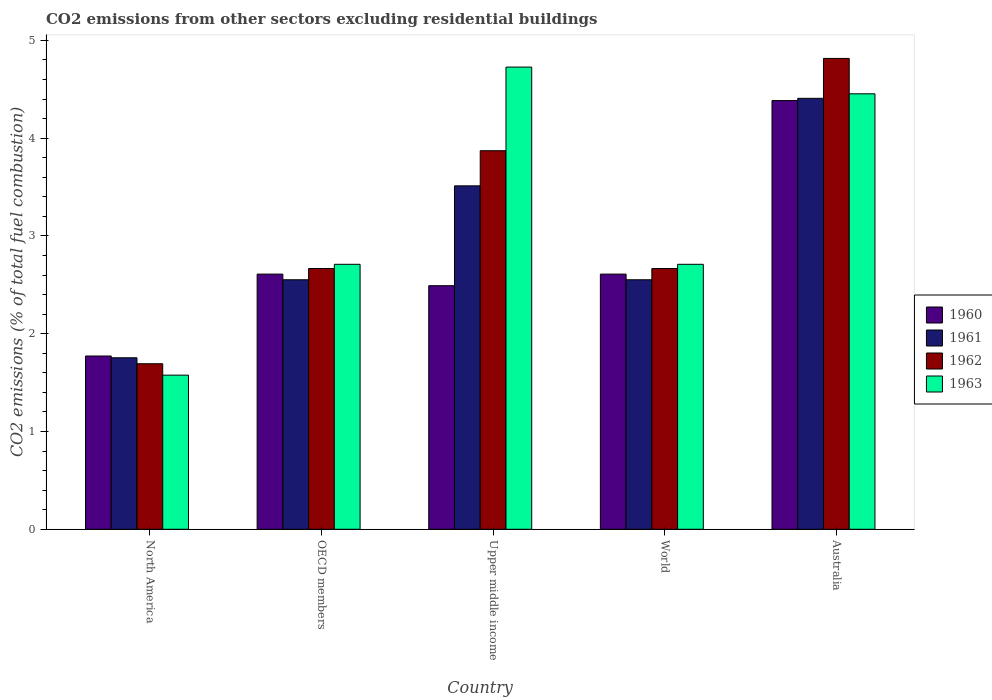How many different coloured bars are there?
Keep it short and to the point. 4. How many groups of bars are there?
Offer a very short reply. 5. Are the number of bars per tick equal to the number of legend labels?
Make the answer very short. Yes. How many bars are there on the 5th tick from the right?
Provide a short and direct response. 4. What is the label of the 2nd group of bars from the left?
Your answer should be compact. OECD members. What is the total CO2 emitted in 1960 in OECD members?
Your response must be concise. 2.61. Across all countries, what is the maximum total CO2 emitted in 1962?
Your answer should be compact. 4.82. Across all countries, what is the minimum total CO2 emitted in 1963?
Your answer should be compact. 1.58. In which country was the total CO2 emitted in 1963 maximum?
Provide a succinct answer. Upper middle income. What is the total total CO2 emitted in 1961 in the graph?
Ensure brevity in your answer.  14.78. What is the difference between the total CO2 emitted in 1961 in Australia and that in World?
Provide a short and direct response. 1.86. What is the difference between the total CO2 emitted in 1963 in Australia and the total CO2 emitted in 1960 in Upper middle income?
Your answer should be compact. 1.96. What is the average total CO2 emitted in 1960 per country?
Ensure brevity in your answer.  2.77. What is the difference between the total CO2 emitted of/in 1962 and total CO2 emitted of/in 1961 in OECD members?
Make the answer very short. 0.11. What is the ratio of the total CO2 emitted in 1961 in Australia to that in World?
Make the answer very short. 1.73. Is the total CO2 emitted in 1963 in North America less than that in Upper middle income?
Offer a terse response. Yes. Is the difference between the total CO2 emitted in 1962 in Australia and World greater than the difference between the total CO2 emitted in 1961 in Australia and World?
Keep it short and to the point. Yes. What is the difference between the highest and the second highest total CO2 emitted in 1962?
Offer a very short reply. -1.2. What is the difference between the highest and the lowest total CO2 emitted in 1960?
Your response must be concise. 2.61. Is the sum of the total CO2 emitted in 1963 in OECD members and World greater than the maximum total CO2 emitted in 1962 across all countries?
Your answer should be very brief. Yes. What does the 2nd bar from the left in North America represents?
Offer a very short reply. 1961. What does the 2nd bar from the right in Australia represents?
Ensure brevity in your answer.  1962. Is it the case that in every country, the sum of the total CO2 emitted in 1960 and total CO2 emitted in 1963 is greater than the total CO2 emitted in 1961?
Your answer should be very brief. Yes. How many bars are there?
Offer a terse response. 20. Are all the bars in the graph horizontal?
Make the answer very short. No. Are the values on the major ticks of Y-axis written in scientific E-notation?
Make the answer very short. No. Does the graph contain any zero values?
Offer a very short reply. No. Where does the legend appear in the graph?
Make the answer very short. Center right. How many legend labels are there?
Provide a succinct answer. 4. How are the legend labels stacked?
Your answer should be compact. Vertical. What is the title of the graph?
Keep it short and to the point. CO2 emissions from other sectors excluding residential buildings. Does "2003" appear as one of the legend labels in the graph?
Offer a very short reply. No. What is the label or title of the X-axis?
Your response must be concise. Country. What is the label or title of the Y-axis?
Your answer should be very brief. CO2 emissions (% of total fuel combustion). What is the CO2 emissions (% of total fuel combustion) in 1960 in North America?
Provide a short and direct response. 1.77. What is the CO2 emissions (% of total fuel combustion) of 1961 in North America?
Keep it short and to the point. 1.75. What is the CO2 emissions (% of total fuel combustion) of 1962 in North America?
Offer a terse response. 1.69. What is the CO2 emissions (% of total fuel combustion) in 1963 in North America?
Your answer should be very brief. 1.58. What is the CO2 emissions (% of total fuel combustion) in 1960 in OECD members?
Your answer should be very brief. 2.61. What is the CO2 emissions (% of total fuel combustion) in 1961 in OECD members?
Keep it short and to the point. 2.55. What is the CO2 emissions (% of total fuel combustion) of 1962 in OECD members?
Ensure brevity in your answer.  2.67. What is the CO2 emissions (% of total fuel combustion) of 1963 in OECD members?
Provide a succinct answer. 2.71. What is the CO2 emissions (% of total fuel combustion) in 1960 in Upper middle income?
Offer a terse response. 2.49. What is the CO2 emissions (% of total fuel combustion) in 1961 in Upper middle income?
Provide a short and direct response. 3.51. What is the CO2 emissions (% of total fuel combustion) in 1962 in Upper middle income?
Your response must be concise. 3.87. What is the CO2 emissions (% of total fuel combustion) in 1963 in Upper middle income?
Make the answer very short. 4.73. What is the CO2 emissions (% of total fuel combustion) of 1960 in World?
Your answer should be compact. 2.61. What is the CO2 emissions (% of total fuel combustion) of 1961 in World?
Ensure brevity in your answer.  2.55. What is the CO2 emissions (% of total fuel combustion) in 1962 in World?
Provide a succinct answer. 2.67. What is the CO2 emissions (% of total fuel combustion) in 1963 in World?
Provide a short and direct response. 2.71. What is the CO2 emissions (% of total fuel combustion) of 1960 in Australia?
Offer a terse response. 4.38. What is the CO2 emissions (% of total fuel combustion) of 1961 in Australia?
Provide a short and direct response. 4.41. What is the CO2 emissions (% of total fuel combustion) of 1962 in Australia?
Give a very brief answer. 4.82. What is the CO2 emissions (% of total fuel combustion) in 1963 in Australia?
Provide a succinct answer. 4.45. Across all countries, what is the maximum CO2 emissions (% of total fuel combustion) of 1960?
Provide a short and direct response. 4.38. Across all countries, what is the maximum CO2 emissions (% of total fuel combustion) in 1961?
Provide a short and direct response. 4.41. Across all countries, what is the maximum CO2 emissions (% of total fuel combustion) of 1962?
Offer a terse response. 4.82. Across all countries, what is the maximum CO2 emissions (% of total fuel combustion) of 1963?
Your response must be concise. 4.73. Across all countries, what is the minimum CO2 emissions (% of total fuel combustion) in 1960?
Offer a very short reply. 1.77. Across all countries, what is the minimum CO2 emissions (% of total fuel combustion) of 1961?
Keep it short and to the point. 1.75. Across all countries, what is the minimum CO2 emissions (% of total fuel combustion) of 1962?
Give a very brief answer. 1.69. Across all countries, what is the minimum CO2 emissions (% of total fuel combustion) in 1963?
Ensure brevity in your answer.  1.58. What is the total CO2 emissions (% of total fuel combustion) in 1960 in the graph?
Your answer should be compact. 13.87. What is the total CO2 emissions (% of total fuel combustion) in 1961 in the graph?
Provide a succinct answer. 14.78. What is the total CO2 emissions (% of total fuel combustion) of 1962 in the graph?
Your response must be concise. 15.71. What is the total CO2 emissions (% of total fuel combustion) of 1963 in the graph?
Ensure brevity in your answer.  16.17. What is the difference between the CO2 emissions (% of total fuel combustion) of 1960 in North America and that in OECD members?
Make the answer very short. -0.84. What is the difference between the CO2 emissions (% of total fuel combustion) in 1961 in North America and that in OECD members?
Ensure brevity in your answer.  -0.8. What is the difference between the CO2 emissions (% of total fuel combustion) of 1962 in North America and that in OECD members?
Give a very brief answer. -0.97. What is the difference between the CO2 emissions (% of total fuel combustion) in 1963 in North America and that in OECD members?
Give a very brief answer. -1.13. What is the difference between the CO2 emissions (% of total fuel combustion) of 1960 in North America and that in Upper middle income?
Provide a succinct answer. -0.72. What is the difference between the CO2 emissions (% of total fuel combustion) of 1961 in North America and that in Upper middle income?
Provide a short and direct response. -1.76. What is the difference between the CO2 emissions (% of total fuel combustion) in 1962 in North America and that in Upper middle income?
Provide a succinct answer. -2.18. What is the difference between the CO2 emissions (% of total fuel combustion) in 1963 in North America and that in Upper middle income?
Ensure brevity in your answer.  -3.15. What is the difference between the CO2 emissions (% of total fuel combustion) in 1960 in North America and that in World?
Offer a terse response. -0.84. What is the difference between the CO2 emissions (% of total fuel combustion) of 1961 in North America and that in World?
Make the answer very short. -0.8. What is the difference between the CO2 emissions (% of total fuel combustion) in 1962 in North America and that in World?
Your answer should be compact. -0.97. What is the difference between the CO2 emissions (% of total fuel combustion) in 1963 in North America and that in World?
Offer a very short reply. -1.13. What is the difference between the CO2 emissions (% of total fuel combustion) of 1960 in North America and that in Australia?
Give a very brief answer. -2.61. What is the difference between the CO2 emissions (% of total fuel combustion) in 1961 in North America and that in Australia?
Offer a very short reply. -2.65. What is the difference between the CO2 emissions (% of total fuel combustion) in 1962 in North America and that in Australia?
Your answer should be compact. -3.12. What is the difference between the CO2 emissions (% of total fuel combustion) of 1963 in North America and that in Australia?
Provide a short and direct response. -2.88. What is the difference between the CO2 emissions (% of total fuel combustion) of 1960 in OECD members and that in Upper middle income?
Provide a short and direct response. 0.12. What is the difference between the CO2 emissions (% of total fuel combustion) of 1961 in OECD members and that in Upper middle income?
Give a very brief answer. -0.96. What is the difference between the CO2 emissions (% of total fuel combustion) of 1962 in OECD members and that in Upper middle income?
Provide a succinct answer. -1.2. What is the difference between the CO2 emissions (% of total fuel combustion) in 1963 in OECD members and that in Upper middle income?
Provide a short and direct response. -2.02. What is the difference between the CO2 emissions (% of total fuel combustion) of 1961 in OECD members and that in World?
Offer a very short reply. 0. What is the difference between the CO2 emissions (% of total fuel combustion) of 1963 in OECD members and that in World?
Your response must be concise. 0. What is the difference between the CO2 emissions (% of total fuel combustion) of 1960 in OECD members and that in Australia?
Offer a very short reply. -1.77. What is the difference between the CO2 emissions (% of total fuel combustion) of 1961 in OECD members and that in Australia?
Your answer should be compact. -1.86. What is the difference between the CO2 emissions (% of total fuel combustion) in 1962 in OECD members and that in Australia?
Keep it short and to the point. -2.15. What is the difference between the CO2 emissions (% of total fuel combustion) of 1963 in OECD members and that in Australia?
Your answer should be very brief. -1.74. What is the difference between the CO2 emissions (% of total fuel combustion) in 1960 in Upper middle income and that in World?
Keep it short and to the point. -0.12. What is the difference between the CO2 emissions (% of total fuel combustion) of 1961 in Upper middle income and that in World?
Ensure brevity in your answer.  0.96. What is the difference between the CO2 emissions (% of total fuel combustion) of 1962 in Upper middle income and that in World?
Make the answer very short. 1.2. What is the difference between the CO2 emissions (% of total fuel combustion) in 1963 in Upper middle income and that in World?
Offer a very short reply. 2.02. What is the difference between the CO2 emissions (% of total fuel combustion) of 1960 in Upper middle income and that in Australia?
Keep it short and to the point. -1.89. What is the difference between the CO2 emissions (% of total fuel combustion) of 1961 in Upper middle income and that in Australia?
Your answer should be very brief. -0.9. What is the difference between the CO2 emissions (% of total fuel combustion) of 1962 in Upper middle income and that in Australia?
Your answer should be compact. -0.94. What is the difference between the CO2 emissions (% of total fuel combustion) of 1963 in Upper middle income and that in Australia?
Make the answer very short. 0.27. What is the difference between the CO2 emissions (% of total fuel combustion) of 1960 in World and that in Australia?
Provide a succinct answer. -1.77. What is the difference between the CO2 emissions (% of total fuel combustion) of 1961 in World and that in Australia?
Provide a succinct answer. -1.86. What is the difference between the CO2 emissions (% of total fuel combustion) of 1962 in World and that in Australia?
Make the answer very short. -2.15. What is the difference between the CO2 emissions (% of total fuel combustion) of 1963 in World and that in Australia?
Offer a terse response. -1.74. What is the difference between the CO2 emissions (% of total fuel combustion) of 1960 in North America and the CO2 emissions (% of total fuel combustion) of 1961 in OECD members?
Your answer should be very brief. -0.78. What is the difference between the CO2 emissions (% of total fuel combustion) of 1960 in North America and the CO2 emissions (% of total fuel combustion) of 1962 in OECD members?
Offer a very short reply. -0.89. What is the difference between the CO2 emissions (% of total fuel combustion) in 1960 in North America and the CO2 emissions (% of total fuel combustion) in 1963 in OECD members?
Your answer should be very brief. -0.94. What is the difference between the CO2 emissions (% of total fuel combustion) of 1961 in North America and the CO2 emissions (% of total fuel combustion) of 1962 in OECD members?
Keep it short and to the point. -0.91. What is the difference between the CO2 emissions (% of total fuel combustion) of 1961 in North America and the CO2 emissions (% of total fuel combustion) of 1963 in OECD members?
Your response must be concise. -0.96. What is the difference between the CO2 emissions (% of total fuel combustion) of 1962 in North America and the CO2 emissions (% of total fuel combustion) of 1963 in OECD members?
Your answer should be very brief. -1.02. What is the difference between the CO2 emissions (% of total fuel combustion) of 1960 in North America and the CO2 emissions (% of total fuel combustion) of 1961 in Upper middle income?
Provide a succinct answer. -1.74. What is the difference between the CO2 emissions (% of total fuel combustion) in 1960 in North America and the CO2 emissions (% of total fuel combustion) in 1962 in Upper middle income?
Keep it short and to the point. -2.1. What is the difference between the CO2 emissions (% of total fuel combustion) in 1960 in North America and the CO2 emissions (% of total fuel combustion) in 1963 in Upper middle income?
Your answer should be compact. -2.95. What is the difference between the CO2 emissions (% of total fuel combustion) of 1961 in North America and the CO2 emissions (% of total fuel combustion) of 1962 in Upper middle income?
Your answer should be very brief. -2.12. What is the difference between the CO2 emissions (% of total fuel combustion) of 1961 in North America and the CO2 emissions (% of total fuel combustion) of 1963 in Upper middle income?
Make the answer very short. -2.97. What is the difference between the CO2 emissions (% of total fuel combustion) in 1962 in North America and the CO2 emissions (% of total fuel combustion) in 1963 in Upper middle income?
Give a very brief answer. -3.03. What is the difference between the CO2 emissions (% of total fuel combustion) of 1960 in North America and the CO2 emissions (% of total fuel combustion) of 1961 in World?
Provide a succinct answer. -0.78. What is the difference between the CO2 emissions (% of total fuel combustion) in 1960 in North America and the CO2 emissions (% of total fuel combustion) in 1962 in World?
Your answer should be compact. -0.89. What is the difference between the CO2 emissions (% of total fuel combustion) of 1960 in North America and the CO2 emissions (% of total fuel combustion) of 1963 in World?
Provide a short and direct response. -0.94. What is the difference between the CO2 emissions (% of total fuel combustion) in 1961 in North America and the CO2 emissions (% of total fuel combustion) in 1962 in World?
Offer a terse response. -0.91. What is the difference between the CO2 emissions (% of total fuel combustion) in 1961 in North America and the CO2 emissions (% of total fuel combustion) in 1963 in World?
Provide a short and direct response. -0.96. What is the difference between the CO2 emissions (% of total fuel combustion) of 1962 in North America and the CO2 emissions (% of total fuel combustion) of 1963 in World?
Your answer should be very brief. -1.02. What is the difference between the CO2 emissions (% of total fuel combustion) of 1960 in North America and the CO2 emissions (% of total fuel combustion) of 1961 in Australia?
Offer a very short reply. -2.64. What is the difference between the CO2 emissions (% of total fuel combustion) of 1960 in North America and the CO2 emissions (% of total fuel combustion) of 1962 in Australia?
Keep it short and to the point. -3.04. What is the difference between the CO2 emissions (% of total fuel combustion) of 1960 in North America and the CO2 emissions (% of total fuel combustion) of 1963 in Australia?
Give a very brief answer. -2.68. What is the difference between the CO2 emissions (% of total fuel combustion) of 1961 in North America and the CO2 emissions (% of total fuel combustion) of 1962 in Australia?
Your answer should be compact. -3.06. What is the difference between the CO2 emissions (% of total fuel combustion) in 1961 in North America and the CO2 emissions (% of total fuel combustion) in 1963 in Australia?
Provide a short and direct response. -2.7. What is the difference between the CO2 emissions (% of total fuel combustion) in 1962 in North America and the CO2 emissions (% of total fuel combustion) in 1963 in Australia?
Offer a very short reply. -2.76. What is the difference between the CO2 emissions (% of total fuel combustion) of 1960 in OECD members and the CO2 emissions (% of total fuel combustion) of 1961 in Upper middle income?
Provide a succinct answer. -0.9. What is the difference between the CO2 emissions (% of total fuel combustion) in 1960 in OECD members and the CO2 emissions (% of total fuel combustion) in 1962 in Upper middle income?
Make the answer very short. -1.26. What is the difference between the CO2 emissions (% of total fuel combustion) of 1960 in OECD members and the CO2 emissions (% of total fuel combustion) of 1963 in Upper middle income?
Give a very brief answer. -2.12. What is the difference between the CO2 emissions (% of total fuel combustion) of 1961 in OECD members and the CO2 emissions (% of total fuel combustion) of 1962 in Upper middle income?
Provide a succinct answer. -1.32. What is the difference between the CO2 emissions (% of total fuel combustion) of 1961 in OECD members and the CO2 emissions (% of total fuel combustion) of 1963 in Upper middle income?
Make the answer very short. -2.17. What is the difference between the CO2 emissions (% of total fuel combustion) in 1962 in OECD members and the CO2 emissions (% of total fuel combustion) in 1963 in Upper middle income?
Your answer should be very brief. -2.06. What is the difference between the CO2 emissions (% of total fuel combustion) in 1960 in OECD members and the CO2 emissions (% of total fuel combustion) in 1961 in World?
Make the answer very short. 0.06. What is the difference between the CO2 emissions (% of total fuel combustion) in 1960 in OECD members and the CO2 emissions (% of total fuel combustion) in 1962 in World?
Ensure brevity in your answer.  -0.06. What is the difference between the CO2 emissions (% of total fuel combustion) of 1960 in OECD members and the CO2 emissions (% of total fuel combustion) of 1963 in World?
Your answer should be compact. -0.1. What is the difference between the CO2 emissions (% of total fuel combustion) in 1961 in OECD members and the CO2 emissions (% of total fuel combustion) in 1962 in World?
Your response must be concise. -0.12. What is the difference between the CO2 emissions (% of total fuel combustion) of 1961 in OECD members and the CO2 emissions (% of total fuel combustion) of 1963 in World?
Provide a succinct answer. -0.16. What is the difference between the CO2 emissions (% of total fuel combustion) in 1962 in OECD members and the CO2 emissions (% of total fuel combustion) in 1963 in World?
Your response must be concise. -0.04. What is the difference between the CO2 emissions (% of total fuel combustion) in 1960 in OECD members and the CO2 emissions (% of total fuel combustion) in 1961 in Australia?
Your answer should be very brief. -1.8. What is the difference between the CO2 emissions (% of total fuel combustion) in 1960 in OECD members and the CO2 emissions (% of total fuel combustion) in 1962 in Australia?
Offer a very short reply. -2.21. What is the difference between the CO2 emissions (% of total fuel combustion) in 1960 in OECD members and the CO2 emissions (% of total fuel combustion) in 1963 in Australia?
Ensure brevity in your answer.  -1.84. What is the difference between the CO2 emissions (% of total fuel combustion) of 1961 in OECD members and the CO2 emissions (% of total fuel combustion) of 1962 in Australia?
Make the answer very short. -2.26. What is the difference between the CO2 emissions (% of total fuel combustion) in 1961 in OECD members and the CO2 emissions (% of total fuel combustion) in 1963 in Australia?
Your answer should be compact. -1.9. What is the difference between the CO2 emissions (% of total fuel combustion) of 1962 in OECD members and the CO2 emissions (% of total fuel combustion) of 1963 in Australia?
Provide a succinct answer. -1.79. What is the difference between the CO2 emissions (% of total fuel combustion) of 1960 in Upper middle income and the CO2 emissions (% of total fuel combustion) of 1961 in World?
Make the answer very short. -0.06. What is the difference between the CO2 emissions (% of total fuel combustion) of 1960 in Upper middle income and the CO2 emissions (% of total fuel combustion) of 1962 in World?
Your answer should be compact. -0.18. What is the difference between the CO2 emissions (% of total fuel combustion) in 1960 in Upper middle income and the CO2 emissions (% of total fuel combustion) in 1963 in World?
Your answer should be very brief. -0.22. What is the difference between the CO2 emissions (% of total fuel combustion) of 1961 in Upper middle income and the CO2 emissions (% of total fuel combustion) of 1962 in World?
Offer a terse response. 0.85. What is the difference between the CO2 emissions (% of total fuel combustion) in 1961 in Upper middle income and the CO2 emissions (% of total fuel combustion) in 1963 in World?
Provide a short and direct response. 0.8. What is the difference between the CO2 emissions (% of total fuel combustion) of 1962 in Upper middle income and the CO2 emissions (% of total fuel combustion) of 1963 in World?
Your answer should be compact. 1.16. What is the difference between the CO2 emissions (% of total fuel combustion) in 1960 in Upper middle income and the CO2 emissions (% of total fuel combustion) in 1961 in Australia?
Provide a succinct answer. -1.92. What is the difference between the CO2 emissions (% of total fuel combustion) of 1960 in Upper middle income and the CO2 emissions (% of total fuel combustion) of 1962 in Australia?
Provide a succinct answer. -2.32. What is the difference between the CO2 emissions (% of total fuel combustion) in 1960 in Upper middle income and the CO2 emissions (% of total fuel combustion) in 1963 in Australia?
Your response must be concise. -1.96. What is the difference between the CO2 emissions (% of total fuel combustion) of 1961 in Upper middle income and the CO2 emissions (% of total fuel combustion) of 1962 in Australia?
Your response must be concise. -1.3. What is the difference between the CO2 emissions (% of total fuel combustion) in 1961 in Upper middle income and the CO2 emissions (% of total fuel combustion) in 1963 in Australia?
Your answer should be very brief. -0.94. What is the difference between the CO2 emissions (% of total fuel combustion) in 1962 in Upper middle income and the CO2 emissions (% of total fuel combustion) in 1963 in Australia?
Offer a terse response. -0.58. What is the difference between the CO2 emissions (% of total fuel combustion) in 1960 in World and the CO2 emissions (% of total fuel combustion) in 1961 in Australia?
Your answer should be very brief. -1.8. What is the difference between the CO2 emissions (% of total fuel combustion) of 1960 in World and the CO2 emissions (% of total fuel combustion) of 1962 in Australia?
Your response must be concise. -2.21. What is the difference between the CO2 emissions (% of total fuel combustion) in 1960 in World and the CO2 emissions (% of total fuel combustion) in 1963 in Australia?
Your response must be concise. -1.84. What is the difference between the CO2 emissions (% of total fuel combustion) of 1961 in World and the CO2 emissions (% of total fuel combustion) of 1962 in Australia?
Give a very brief answer. -2.26. What is the difference between the CO2 emissions (% of total fuel combustion) in 1961 in World and the CO2 emissions (% of total fuel combustion) in 1963 in Australia?
Offer a terse response. -1.9. What is the difference between the CO2 emissions (% of total fuel combustion) in 1962 in World and the CO2 emissions (% of total fuel combustion) in 1963 in Australia?
Offer a very short reply. -1.79. What is the average CO2 emissions (% of total fuel combustion) in 1960 per country?
Offer a very short reply. 2.77. What is the average CO2 emissions (% of total fuel combustion) in 1961 per country?
Provide a succinct answer. 2.96. What is the average CO2 emissions (% of total fuel combustion) of 1962 per country?
Give a very brief answer. 3.14. What is the average CO2 emissions (% of total fuel combustion) of 1963 per country?
Keep it short and to the point. 3.23. What is the difference between the CO2 emissions (% of total fuel combustion) of 1960 and CO2 emissions (% of total fuel combustion) of 1961 in North America?
Provide a succinct answer. 0.02. What is the difference between the CO2 emissions (% of total fuel combustion) of 1960 and CO2 emissions (% of total fuel combustion) of 1962 in North America?
Ensure brevity in your answer.  0.08. What is the difference between the CO2 emissions (% of total fuel combustion) of 1960 and CO2 emissions (% of total fuel combustion) of 1963 in North America?
Your answer should be compact. 0.2. What is the difference between the CO2 emissions (% of total fuel combustion) in 1961 and CO2 emissions (% of total fuel combustion) in 1962 in North America?
Give a very brief answer. 0.06. What is the difference between the CO2 emissions (% of total fuel combustion) of 1961 and CO2 emissions (% of total fuel combustion) of 1963 in North America?
Your answer should be compact. 0.18. What is the difference between the CO2 emissions (% of total fuel combustion) in 1962 and CO2 emissions (% of total fuel combustion) in 1963 in North America?
Keep it short and to the point. 0.12. What is the difference between the CO2 emissions (% of total fuel combustion) in 1960 and CO2 emissions (% of total fuel combustion) in 1961 in OECD members?
Offer a terse response. 0.06. What is the difference between the CO2 emissions (% of total fuel combustion) in 1960 and CO2 emissions (% of total fuel combustion) in 1962 in OECD members?
Offer a very short reply. -0.06. What is the difference between the CO2 emissions (% of total fuel combustion) in 1960 and CO2 emissions (% of total fuel combustion) in 1963 in OECD members?
Ensure brevity in your answer.  -0.1. What is the difference between the CO2 emissions (% of total fuel combustion) in 1961 and CO2 emissions (% of total fuel combustion) in 1962 in OECD members?
Your answer should be compact. -0.12. What is the difference between the CO2 emissions (% of total fuel combustion) in 1961 and CO2 emissions (% of total fuel combustion) in 1963 in OECD members?
Your response must be concise. -0.16. What is the difference between the CO2 emissions (% of total fuel combustion) in 1962 and CO2 emissions (% of total fuel combustion) in 1963 in OECD members?
Your response must be concise. -0.04. What is the difference between the CO2 emissions (% of total fuel combustion) of 1960 and CO2 emissions (% of total fuel combustion) of 1961 in Upper middle income?
Your response must be concise. -1.02. What is the difference between the CO2 emissions (% of total fuel combustion) in 1960 and CO2 emissions (% of total fuel combustion) in 1962 in Upper middle income?
Provide a succinct answer. -1.38. What is the difference between the CO2 emissions (% of total fuel combustion) in 1960 and CO2 emissions (% of total fuel combustion) in 1963 in Upper middle income?
Provide a succinct answer. -2.24. What is the difference between the CO2 emissions (% of total fuel combustion) of 1961 and CO2 emissions (% of total fuel combustion) of 1962 in Upper middle income?
Ensure brevity in your answer.  -0.36. What is the difference between the CO2 emissions (% of total fuel combustion) in 1961 and CO2 emissions (% of total fuel combustion) in 1963 in Upper middle income?
Ensure brevity in your answer.  -1.21. What is the difference between the CO2 emissions (% of total fuel combustion) of 1962 and CO2 emissions (% of total fuel combustion) of 1963 in Upper middle income?
Your answer should be very brief. -0.85. What is the difference between the CO2 emissions (% of total fuel combustion) in 1960 and CO2 emissions (% of total fuel combustion) in 1961 in World?
Provide a succinct answer. 0.06. What is the difference between the CO2 emissions (% of total fuel combustion) of 1960 and CO2 emissions (% of total fuel combustion) of 1962 in World?
Keep it short and to the point. -0.06. What is the difference between the CO2 emissions (% of total fuel combustion) of 1960 and CO2 emissions (% of total fuel combustion) of 1963 in World?
Give a very brief answer. -0.1. What is the difference between the CO2 emissions (% of total fuel combustion) of 1961 and CO2 emissions (% of total fuel combustion) of 1962 in World?
Offer a terse response. -0.12. What is the difference between the CO2 emissions (% of total fuel combustion) in 1961 and CO2 emissions (% of total fuel combustion) in 1963 in World?
Your response must be concise. -0.16. What is the difference between the CO2 emissions (% of total fuel combustion) in 1962 and CO2 emissions (% of total fuel combustion) in 1963 in World?
Offer a terse response. -0.04. What is the difference between the CO2 emissions (% of total fuel combustion) in 1960 and CO2 emissions (% of total fuel combustion) in 1961 in Australia?
Your answer should be compact. -0.02. What is the difference between the CO2 emissions (% of total fuel combustion) in 1960 and CO2 emissions (% of total fuel combustion) in 1962 in Australia?
Offer a terse response. -0.43. What is the difference between the CO2 emissions (% of total fuel combustion) in 1960 and CO2 emissions (% of total fuel combustion) in 1963 in Australia?
Ensure brevity in your answer.  -0.07. What is the difference between the CO2 emissions (% of total fuel combustion) in 1961 and CO2 emissions (% of total fuel combustion) in 1962 in Australia?
Make the answer very short. -0.41. What is the difference between the CO2 emissions (% of total fuel combustion) in 1961 and CO2 emissions (% of total fuel combustion) in 1963 in Australia?
Ensure brevity in your answer.  -0.05. What is the difference between the CO2 emissions (% of total fuel combustion) of 1962 and CO2 emissions (% of total fuel combustion) of 1963 in Australia?
Keep it short and to the point. 0.36. What is the ratio of the CO2 emissions (% of total fuel combustion) in 1960 in North America to that in OECD members?
Your answer should be compact. 0.68. What is the ratio of the CO2 emissions (% of total fuel combustion) of 1961 in North America to that in OECD members?
Provide a succinct answer. 0.69. What is the ratio of the CO2 emissions (% of total fuel combustion) of 1962 in North America to that in OECD members?
Give a very brief answer. 0.63. What is the ratio of the CO2 emissions (% of total fuel combustion) in 1963 in North America to that in OECD members?
Make the answer very short. 0.58. What is the ratio of the CO2 emissions (% of total fuel combustion) in 1960 in North America to that in Upper middle income?
Offer a very short reply. 0.71. What is the ratio of the CO2 emissions (% of total fuel combustion) in 1961 in North America to that in Upper middle income?
Offer a very short reply. 0.5. What is the ratio of the CO2 emissions (% of total fuel combustion) in 1962 in North America to that in Upper middle income?
Offer a terse response. 0.44. What is the ratio of the CO2 emissions (% of total fuel combustion) in 1963 in North America to that in Upper middle income?
Make the answer very short. 0.33. What is the ratio of the CO2 emissions (% of total fuel combustion) in 1960 in North America to that in World?
Provide a short and direct response. 0.68. What is the ratio of the CO2 emissions (% of total fuel combustion) in 1961 in North America to that in World?
Provide a short and direct response. 0.69. What is the ratio of the CO2 emissions (% of total fuel combustion) of 1962 in North America to that in World?
Provide a succinct answer. 0.63. What is the ratio of the CO2 emissions (% of total fuel combustion) in 1963 in North America to that in World?
Offer a terse response. 0.58. What is the ratio of the CO2 emissions (% of total fuel combustion) in 1960 in North America to that in Australia?
Your answer should be compact. 0.4. What is the ratio of the CO2 emissions (% of total fuel combustion) of 1961 in North America to that in Australia?
Your answer should be compact. 0.4. What is the ratio of the CO2 emissions (% of total fuel combustion) in 1962 in North America to that in Australia?
Give a very brief answer. 0.35. What is the ratio of the CO2 emissions (% of total fuel combustion) in 1963 in North America to that in Australia?
Give a very brief answer. 0.35. What is the ratio of the CO2 emissions (% of total fuel combustion) in 1960 in OECD members to that in Upper middle income?
Keep it short and to the point. 1.05. What is the ratio of the CO2 emissions (% of total fuel combustion) in 1961 in OECD members to that in Upper middle income?
Your answer should be compact. 0.73. What is the ratio of the CO2 emissions (% of total fuel combustion) in 1962 in OECD members to that in Upper middle income?
Offer a terse response. 0.69. What is the ratio of the CO2 emissions (% of total fuel combustion) of 1963 in OECD members to that in Upper middle income?
Keep it short and to the point. 0.57. What is the ratio of the CO2 emissions (% of total fuel combustion) in 1960 in OECD members to that in World?
Ensure brevity in your answer.  1. What is the ratio of the CO2 emissions (% of total fuel combustion) in 1961 in OECD members to that in World?
Your answer should be very brief. 1. What is the ratio of the CO2 emissions (% of total fuel combustion) of 1962 in OECD members to that in World?
Your answer should be very brief. 1. What is the ratio of the CO2 emissions (% of total fuel combustion) of 1963 in OECD members to that in World?
Provide a succinct answer. 1. What is the ratio of the CO2 emissions (% of total fuel combustion) of 1960 in OECD members to that in Australia?
Provide a succinct answer. 0.6. What is the ratio of the CO2 emissions (% of total fuel combustion) in 1961 in OECD members to that in Australia?
Keep it short and to the point. 0.58. What is the ratio of the CO2 emissions (% of total fuel combustion) of 1962 in OECD members to that in Australia?
Keep it short and to the point. 0.55. What is the ratio of the CO2 emissions (% of total fuel combustion) of 1963 in OECD members to that in Australia?
Make the answer very short. 0.61. What is the ratio of the CO2 emissions (% of total fuel combustion) in 1960 in Upper middle income to that in World?
Make the answer very short. 0.95. What is the ratio of the CO2 emissions (% of total fuel combustion) of 1961 in Upper middle income to that in World?
Give a very brief answer. 1.38. What is the ratio of the CO2 emissions (% of total fuel combustion) in 1962 in Upper middle income to that in World?
Ensure brevity in your answer.  1.45. What is the ratio of the CO2 emissions (% of total fuel combustion) of 1963 in Upper middle income to that in World?
Your answer should be compact. 1.74. What is the ratio of the CO2 emissions (% of total fuel combustion) in 1960 in Upper middle income to that in Australia?
Your answer should be very brief. 0.57. What is the ratio of the CO2 emissions (% of total fuel combustion) of 1961 in Upper middle income to that in Australia?
Offer a very short reply. 0.8. What is the ratio of the CO2 emissions (% of total fuel combustion) in 1962 in Upper middle income to that in Australia?
Ensure brevity in your answer.  0.8. What is the ratio of the CO2 emissions (% of total fuel combustion) of 1963 in Upper middle income to that in Australia?
Offer a terse response. 1.06. What is the ratio of the CO2 emissions (% of total fuel combustion) of 1960 in World to that in Australia?
Provide a succinct answer. 0.6. What is the ratio of the CO2 emissions (% of total fuel combustion) in 1961 in World to that in Australia?
Your answer should be compact. 0.58. What is the ratio of the CO2 emissions (% of total fuel combustion) in 1962 in World to that in Australia?
Keep it short and to the point. 0.55. What is the ratio of the CO2 emissions (% of total fuel combustion) in 1963 in World to that in Australia?
Your response must be concise. 0.61. What is the difference between the highest and the second highest CO2 emissions (% of total fuel combustion) in 1960?
Provide a short and direct response. 1.77. What is the difference between the highest and the second highest CO2 emissions (% of total fuel combustion) in 1961?
Give a very brief answer. 0.9. What is the difference between the highest and the second highest CO2 emissions (% of total fuel combustion) in 1962?
Offer a terse response. 0.94. What is the difference between the highest and the second highest CO2 emissions (% of total fuel combustion) of 1963?
Keep it short and to the point. 0.27. What is the difference between the highest and the lowest CO2 emissions (% of total fuel combustion) in 1960?
Offer a very short reply. 2.61. What is the difference between the highest and the lowest CO2 emissions (% of total fuel combustion) in 1961?
Provide a short and direct response. 2.65. What is the difference between the highest and the lowest CO2 emissions (% of total fuel combustion) of 1962?
Your answer should be very brief. 3.12. What is the difference between the highest and the lowest CO2 emissions (% of total fuel combustion) of 1963?
Offer a terse response. 3.15. 